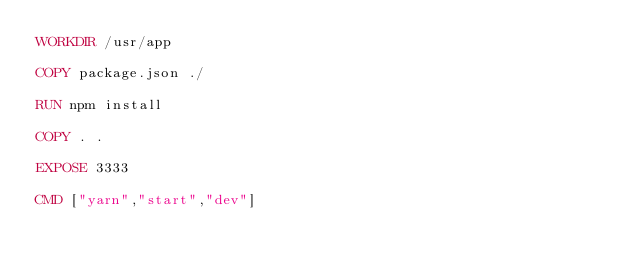Convert code to text. <code><loc_0><loc_0><loc_500><loc_500><_Dockerfile_>WORKDIR /usr/app

COPY package.json ./

RUN npm install

COPY . .

EXPOSE 3333

CMD ["yarn","start","dev"]</code> 